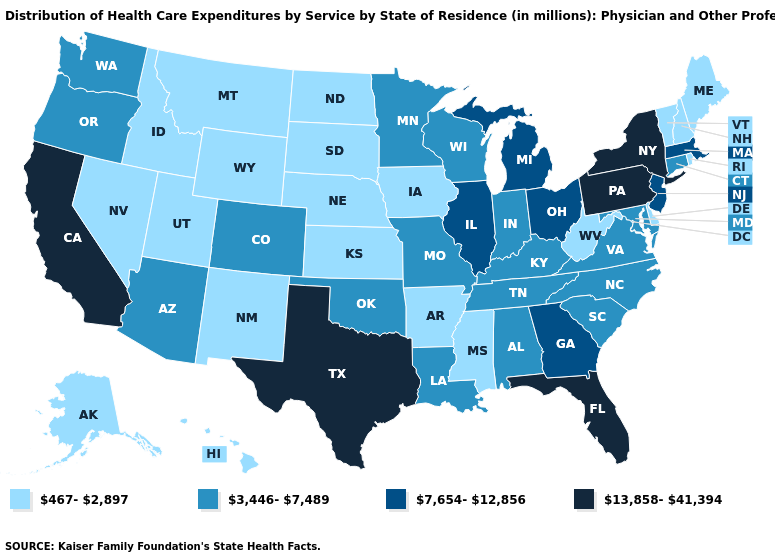What is the value of Virginia?
Short answer required. 3,446-7,489. What is the value of Nevada?
Be succinct. 467-2,897. Name the states that have a value in the range 3,446-7,489?
Be succinct. Alabama, Arizona, Colorado, Connecticut, Indiana, Kentucky, Louisiana, Maryland, Minnesota, Missouri, North Carolina, Oklahoma, Oregon, South Carolina, Tennessee, Virginia, Washington, Wisconsin. Does Connecticut have a lower value than North Carolina?
Short answer required. No. Does the first symbol in the legend represent the smallest category?
Short answer required. Yes. What is the lowest value in the USA?
Short answer required. 467-2,897. Which states have the lowest value in the South?
Write a very short answer. Arkansas, Delaware, Mississippi, West Virginia. Does California have the lowest value in the USA?
Quick response, please. No. Name the states that have a value in the range 467-2,897?
Keep it brief. Alaska, Arkansas, Delaware, Hawaii, Idaho, Iowa, Kansas, Maine, Mississippi, Montana, Nebraska, Nevada, New Hampshire, New Mexico, North Dakota, Rhode Island, South Dakota, Utah, Vermont, West Virginia, Wyoming. What is the value of Virginia?
Write a very short answer. 3,446-7,489. What is the value of South Dakota?
Quick response, please. 467-2,897. Name the states that have a value in the range 3,446-7,489?
Be succinct. Alabama, Arizona, Colorado, Connecticut, Indiana, Kentucky, Louisiana, Maryland, Minnesota, Missouri, North Carolina, Oklahoma, Oregon, South Carolina, Tennessee, Virginia, Washington, Wisconsin. Among the states that border Kentucky , which have the lowest value?
Keep it brief. West Virginia. Name the states that have a value in the range 13,858-41,394?
Be succinct. California, Florida, New York, Pennsylvania, Texas. What is the highest value in the West ?
Concise answer only. 13,858-41,394. 